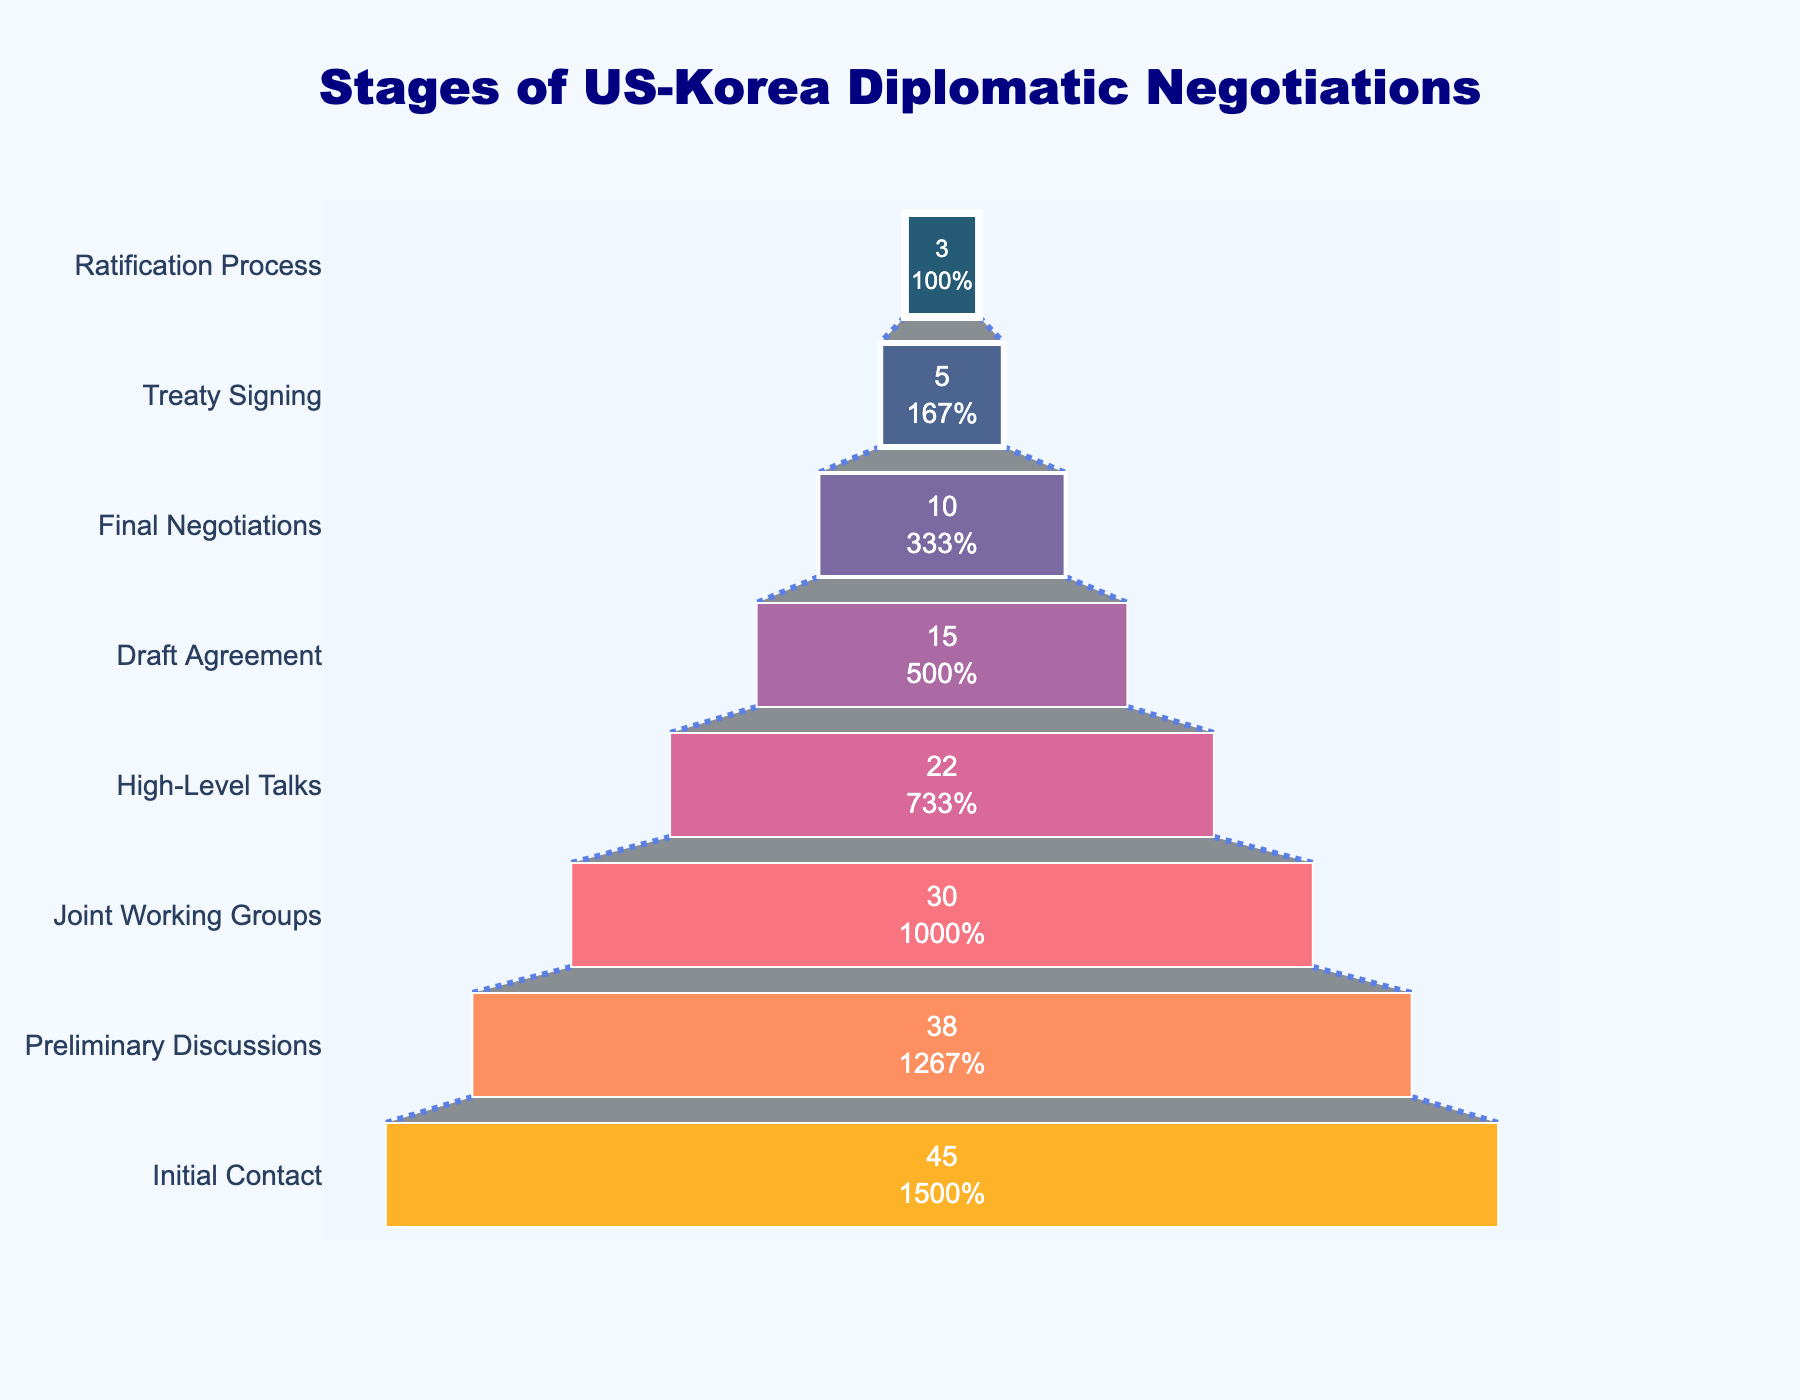what is the title of the figure? The title of the figure is usually placed at the top and it summarizes the content of the chart. For this particular funnel chart, the title indicates what the stages of the US-Korea diplomatic negotiations are.
Answer: Stages of US-Korea Diplomatic Negotiations How many stages are depicted in the chart? To find the number of stages, count the total number of different stages listed along the y-axis.
Answer: 8 At which stage do the number of meetings drop below 20? Identify the stages by their names on the y-axis and locate the meeting counts on the x-axis. The drop below 20 meetings can be observed at the "High-Level Talks" stage.
Answer: High-Level Talks What is the percentage drop of meetings from 'Initial Contact' to 'Treaty Signing'? Calculate the initial number of meetings and the final number of meetings, then use the percentage change formula: [(Initial - Final) / Initial] * 100. So, [(45 - 5) / 45] * 100 = 88.89%.
Answer: 88.89% Which two consecutive stages experienced the most significant drop in the number of meetings? Compare the number of meetings between each pair of consecutive stages to identify the largest drop. The largest difference is between 'Draft Agreement' (15) and 'Final Negotiations' (10), a drop of 5 meetings.
Answer: Draft Agreement to Final Negotiations What percentage of the initial meetings continue to the 'Final Negotiations' stage? Take the number of final negotiations meetings, divide it by the initial contact meetings, and multiply by 100 to get the percentage. So, (10/45) * 100 ≈ 22.22%.
Answer: 22.22% How many more meetings were there in the 'Preliminary Discussions' stage compared to the 'Treaty Signing' stage? Subtract the number of meetings at 'Treaty Signing' from the number of meetings at 'Preliminary Discussions'. So, 38 - 5 = 33 meetings.
Answer: 33 How does the width of the funnel change from 'Joint Working Groups' to 'Draft Agreement'? The width of the funnel represents the number of meetings. Therefore, observe and compare the width of the funnel between 'Joint Working Groups' (30 meetings) and 'Draft Agreement' (15 meetings). The width decreases as the number of meetings is halved.
Answer: Decreases Which stage has the same number of meetings as the 'Final Negotiations' stage has after some were removed? Look at the meetings for the 'Final Negotiations' stage (10) and identify which other stage has the same number of meetings. The 'High-Level Talks' stage has 22 meetings which are approximately double the 'Final Negotiations'. Ratsfied a reout. Qing at ratifies.
Answer: None 